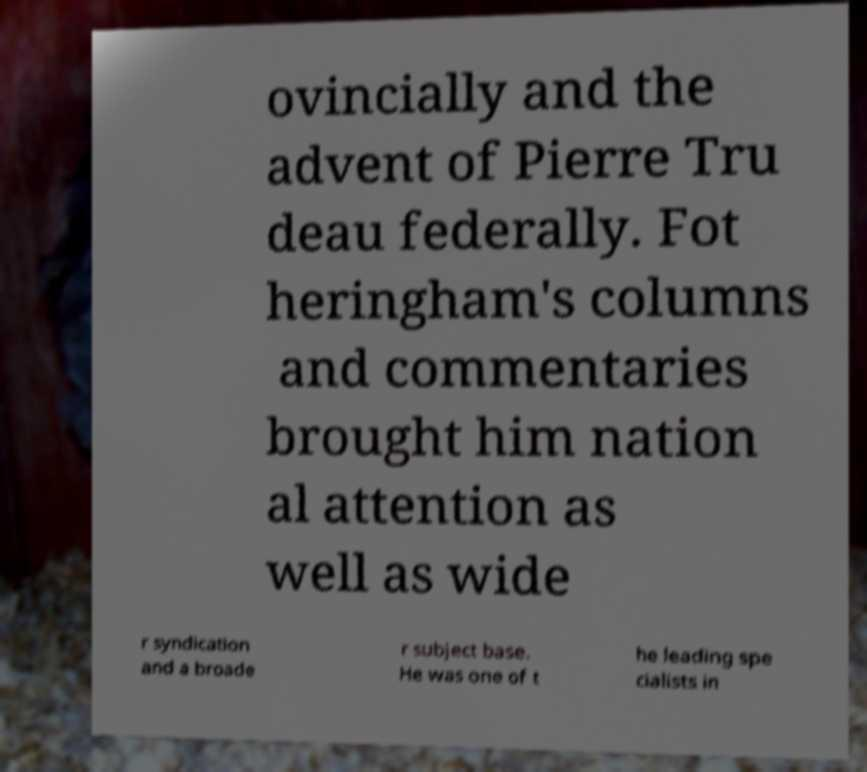Please identify and transcribe the text found in this image. ovincially and the advent of Pierre Tru deau federally. Fot heringham's columns and commentaries brought him nation al attention as well as wide r syndication and a broade r subject base. He was one of t he leading spe cialists in 